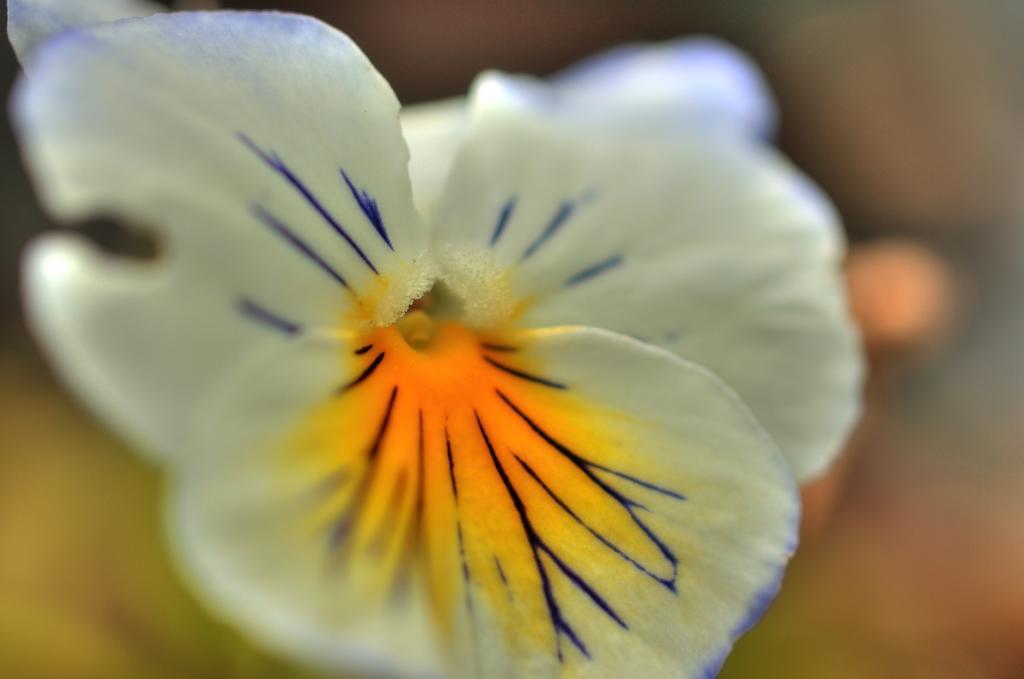Describe this image in one or two sentences. In this image we can see a flower. 